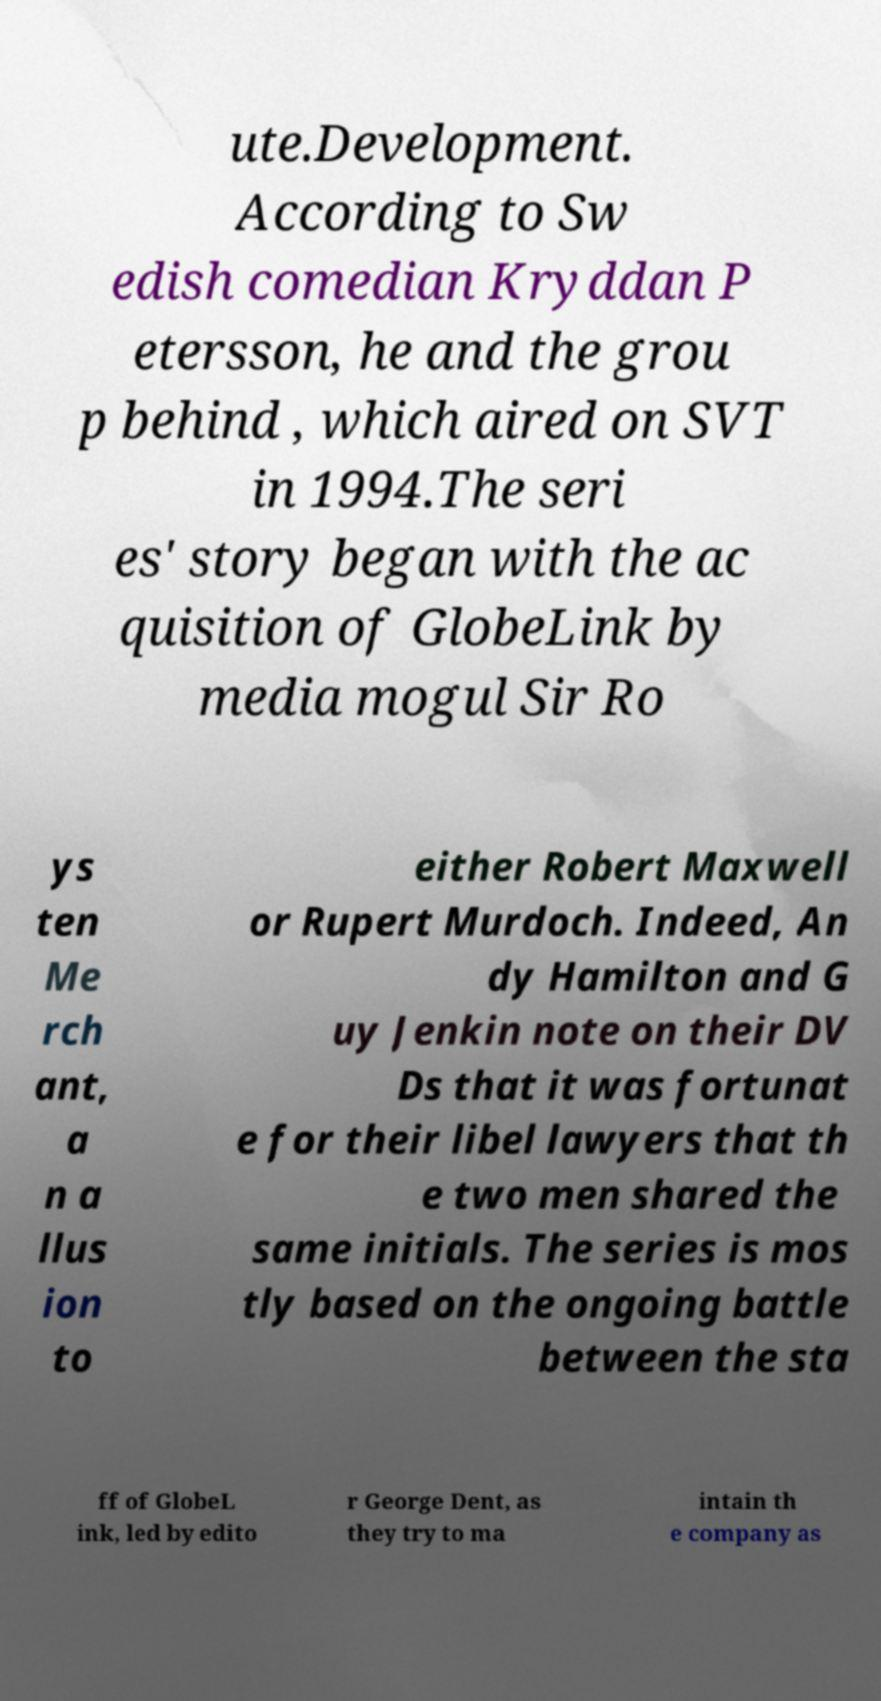Could you assist in decoding the text presented in this image and type it out clearly? ute.Development. According to Sw edish comedian Kryddan P etersson, he and the grou p behind , which aired on SVT in 1994.The seri es' story began with the ac quisition of GlobeLink by media mogul Sir Ro ys ten Me rch ant, a n a llus ion to either Robert Maxwell or Rupert Murdoch. Indeed, An dy Hamilton and G uy Jenkin note on their DV Ds that it was fortunat e for their libel lawyers that th e two men shared the same initials. The series is mos tly based on the ongoing battle between the sta ff of GlobeL ink, led by edito r George Dent, as they try to ma intain th e company as 